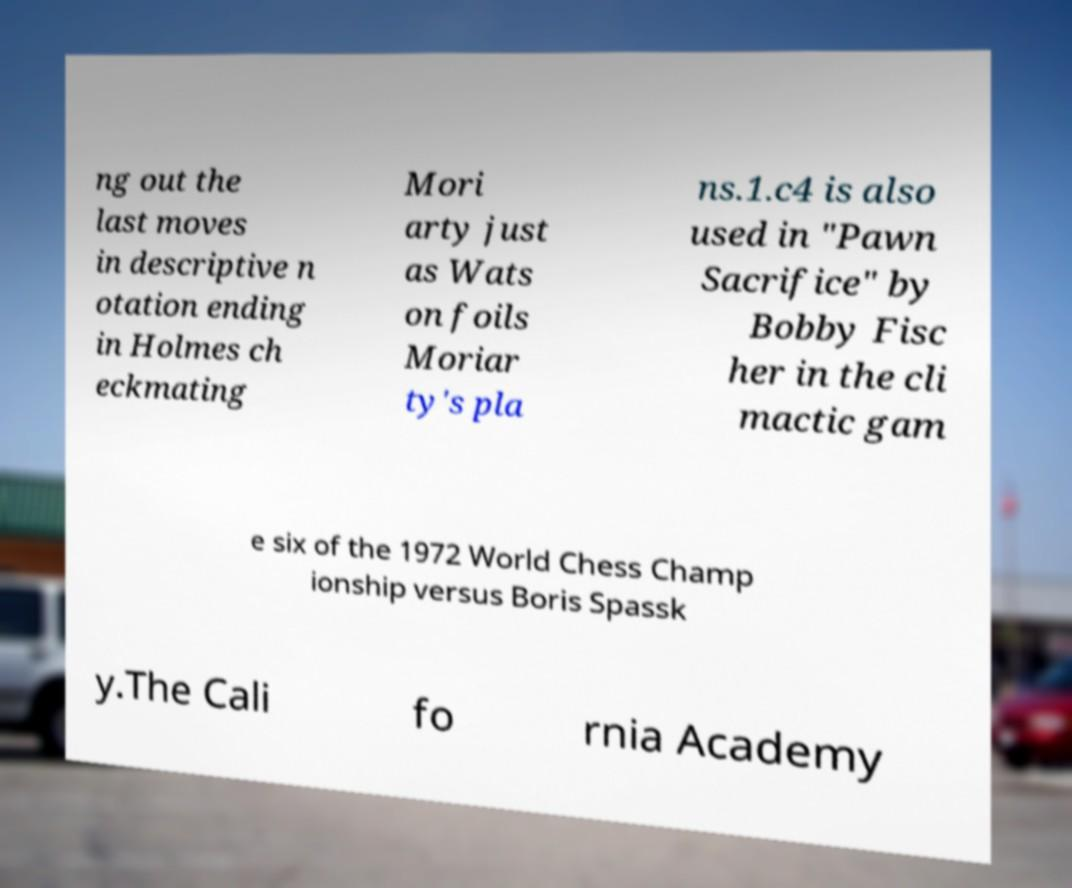I need the written content from this picture converted into text. Can you do that? ng out the last moves in descriptive n otation ending in Holmes ch eckmating Mori arty just as Wats on foils Moriar ty's pla ns.1.c4 is also used in "Pawn Sacrifice" by Bobby Fisc her in the cli mactic gam e six of the 1972 World Chess Champ ionship versus Boris Spassk y.The Cali fo rnia Academy 